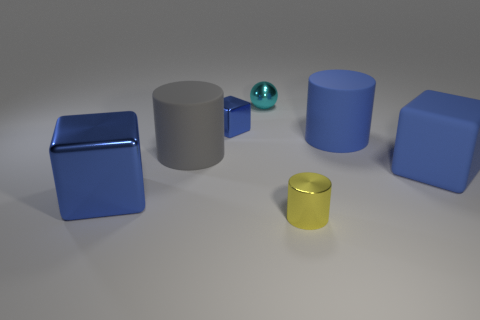Are there fewer blue rubber blocks that are to the left of the large blue matte cylinder than small shiny balls?
Your answer should be compact. Yes. What number of other things are the same shape as the tiny blue metallic thing?
Offer a terse response. 2. How many objects are blue blocks on the left side of the big matte block or blue cubes behind the large gray matte cylinder?
Provide a short and direct response. 2. There is a cylinder that is right of the cyan sphere and behind the tiny yellow object; what size is it?
Make the answer very short. Large. There is a small thing that is behind the small blue metal block; is it the same shape as the yellow object?
Make the answer very short. No. What is the size of the metallic block that is left of the tiny blue shiny thing that is behind the blue shiny object that is in front of the big blue matte block?
Make the answer very short. Large. What is the size of the matte cylinder that is the same color as the large rubber block?
Keep it short and to the point. Large. How many things are blue rubber objects or small blue cubes?
Your answer should be compact. 3. The object that is both in front of the blue matte block and on the left side of the small metal cylinder has what shape?
Your response must be concise. Cube. Does the tiny yellow shiny thing have the same shape as the object behind the tiny blue metal cube?
Give a very brief answer. No. 